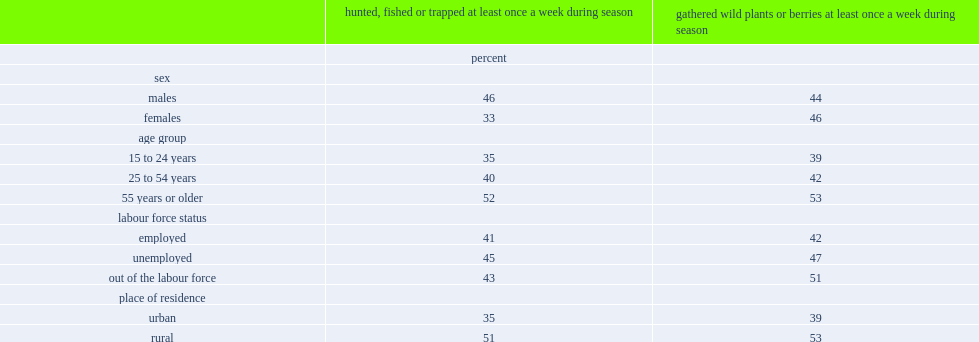Which sex was more likely to hunt, fish or trap at a higher frequency, male or female? Males. Which age group of adults were significantly more likely to hunt, fish or trap at a higher frequency, youth and young adults or older adults? 55 years or older. Which age group of adults were significantly more likely to hunt, fish or trap at a higher frequency, core working-age adults or older adults? 55 years or older. Which area of people were significantly more likely to hunt, fish or trap at a higher frequency, among those in rural or urban areas? Rural. 